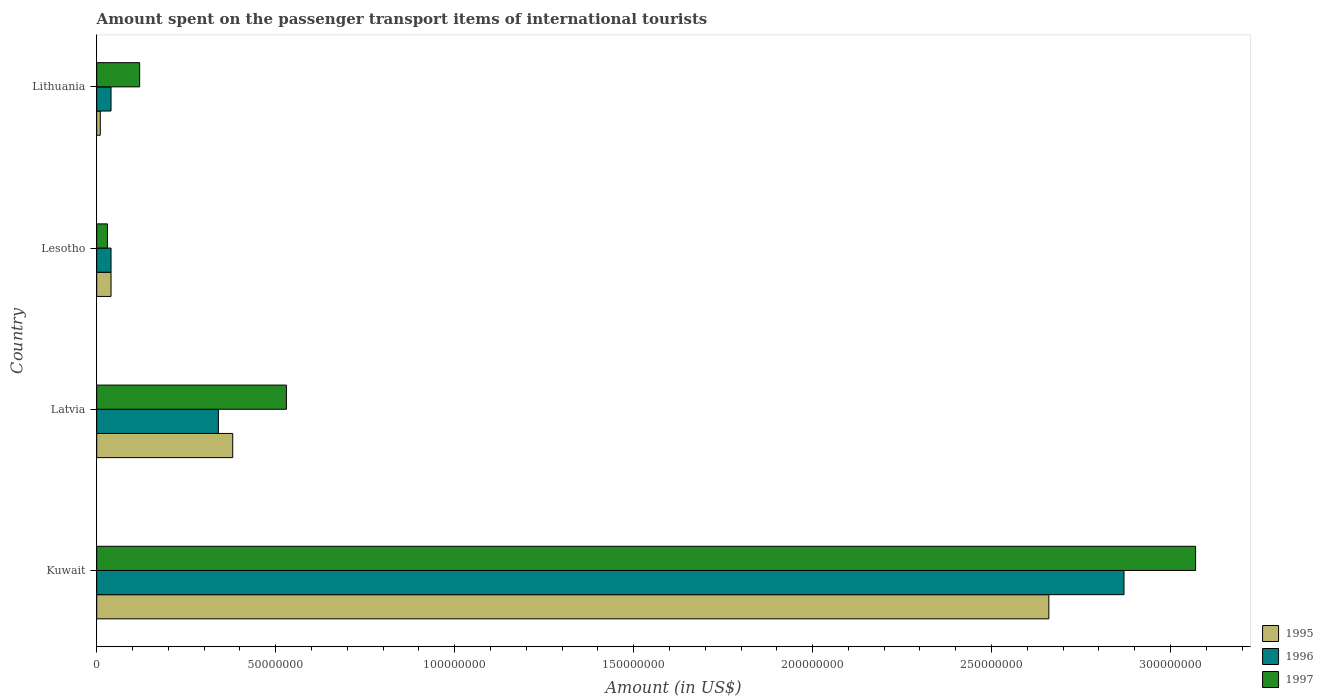How many different coloured bars are there?
Provide a short and direct response. 3. How many groups of bars are there?
Offer a very short reply. 4. Are the number of bars per tick equal to the number of legend labels?
Give a very brief answer. Yes. How many bars are there on the 3rd tick from the top?
Keep it short and to the point. 3. How many bars are there on the 4th tick from the bottom?
Offer a terse response. 3. What is the label of the 2nd group of bars from the top?
Ensure brevity in your answer.  Lesotho. In how many cases, is the number of bars for a given country not equal to the number of legend labels?
Your response must be concise. 0. Across all countries, what is the maximum amount spent on the passenger transport items of international tourists in 1997?
Keep it short and to the point. 3.07e+08. In which country was the amount spent on the passenger transport items of international tourists in 1996 maximum?
Make the answer very short. Kuwait. In which country was the amount spent on the passenger transport items of international tourists in 1996 minimum?
Offer a terse response. Lesotho. What is the total amount spent on the passenger transport items of international tourists in 1997 in the graph?
Make the answer very short. 3.75e+08. What is the difference between the amount spent on the passenger transport items of international tourists in 1995 in Kuwait and the amount spent on the passenger transport items of international tourists in 1996 in Lithuania?
Your response must be concise. 2.62e+08. What is the average amount spent on the passenger transport items of international tourists in 1997 per country?
Give a very brief answer. 9.38e+07. What is the difference between the amount spent on the passenger transport items of international tourists in 1997 and amount spent on the passenger transport items of international tourists in 1995 in Lithuania?
Offer a very short reply. 1.10e+07. What is the ratio of the amount spent on the passenger transport items of international tourists in 1996 in Latvia to that in Lithuania?
Ensure brevity in your answer.  8.5. Is the amount spent on the passenger transport items of international tourists in 1997 in Kuwait less than that in Lesotho?
Your answer should be very brief. No. Is the difference between the amount spent on the passenger transport items of international tourists in 1997 in Kuwait and Lesotho greater than the difference between the amount spent on the passenger transport items of international tourists in 1995 in Kuwait and Lesotho?
Offer a very short reply. Yes. What is the difference between the highest and the second highest amount spent on the passenger transport items of international tourists in 1995?
Give a very brief answer. 2.28e+08. What is the difference between the highest and the lowest amount spent on the passenger transport items of international tourists in 1996?
Your answer should be compact. 2.83e+08. In how many countries, is the amount spent on the passenger transport items of international tourists in 1996 greater than the average amount spent on the passenger transport items of international tourists in 1996 taken over all countries?
Your answer should be compact. 1. What does the 3rd bar from the top in Kuwait represents?
Make the answer very short. 1995. What does the 2nd bar from the bottom in Lesotho represents?
Provide a short and direct response. 1996. Is it the case that in every country, the sum of the amount spent on the passenger transport items of international tourists in 1995 and amount spent on the passenger transport items of international tourists in 1996 is greater than the amount spent on the passenger transport items of international tourists in 1997?
Provide a short and direct response. No. What is the difference between two consecutive major ticks on the X-axis?
Provide a succinct answer. 5.00e+07. Does the graph contain any zero values?
Your answer should be compact. No. Where does the legend appear in the graph?
Offer a terse response. Bottom right. How many legend labels are there?
Provide a short and direct response. 3. How are the legend labels stacked?
Your answer should be compact. Vertical. What is the title of the graph?
Offer a terse response. Amount spent on the passenger transport items of international tourists. What is the Amount (in US$) in 1995 in Kuwait?
Your answer should be compact. 2.66e+08. What is the Amount (in US$) of 1996 in Kuwait?
Your answer should be compact. 2.87e+08. What is the Amount (in US$) of 1997 in Kuwait?
Your response must be concise. 3.07e+08. What is the Amount (in US$) of 1995 in Latvia?
Provide a short and direct response. 3.80e+07. What is the Amount (in US$) of 1996 in Latvia?
Your answer should be compact. 3.40e+07. What is the Amount (in US$) in 1997 in Latvia?
Your response must be concise. 5.30e+07. What is the Amount (in US$) in 1995 in Lesotho?
Your answer should be very brief. 4.00e+06. What is the Amount (in US$) of 1996 in Lesotho?
Offer a terse response. 4.00e+06. What is the Amount (in US$) in 1997 in Lesotho?
Keep it short and to the point. 3.00e+06. What is the Amount (in US$) in 1996 in Lithuania?
Offer a terse response. 4.00e+06. What is the Amount (in US$) of 1997 in Lithuania?
Offer a very short reply. 1.20e+07. Across all countries, what is the maximum Amount (in US$) in 1995?
Make the answer very short. 2.66e+08. Across all countries, what is the maximum Amount (in US$) in 1996?
Provide a short and direct response. 2.87e+08. Across all countries, what is the maximum Amount (in US$) of 1997?
Offer a very short reply. 3.07e+08. Across all countries, what is the minimum Amount (in US$) in 1995?
Ensure brevity in your answer.  1.00e+06. What is the total Amount (in US$) in 1995 in the graph?
Your answer should be compact. 3.09e+08. What is the total Amount (in US$) of 1996 in the graph?
Provide a short and direct response. 3.29e+08. What is the total Amount (in US$) of 1997 in the graph?
Your response must be concise. 3.75e+08. What is the difference between the Amount (in US$) of 1995 in Kuwait and that in Latvia?
Offer a terse response. 2.28e+08. What is the difference between the Amount (in US$) in 1996 in Kuwait and that in Latvia?
Your response must be concise. 2.53e+08. What is the difference between the Amount (in US$) in 1997 in Kuwait and that in Latvia?
Offer a terse response. 2.54e+08. What is the difference between the Amount (in US$) of 1995 in Kuwait and that in Lesotho?
Provide a succinct answer. 2.62e+08. What is the difference between the Amount (in US$) in 1996 in Kuwait and that in Lesotho?
Offer a terse response. 2.83e+08. What is the difference between the Amount (in US$) of 1997 in Kuwait and that in Lesotho?
Ensure brevity in your answer.  3.04e+08. What is the difference between the Amount (in US$) of 1995 in Kuwait and that in Lithuania?
Offer a terse response. 2.65e+08. What is the difference between the Amount (in US$) in 1996 in Kuwait and that in Lithuania?
Make the answer very short. 2.83e+08. What is the difference between the Amount (in US$) of 1997 in Kuwait and that in Lithuania?
Your answer should be compact. 2.95e+08. What is the difference between the Amount (in US$) of 1995 in Latvia and that in Lesotho?
Offer a very short reply. 3.40e+07. What is the difference between the Amount (in US$) in 1996 in Latvia and that in Lesotho?
Ensure brevity in your answer.  3.00e+07. What is the difference between the Amount (in US$) in 1995 in Latvia and that in Lithuania?
Give a very brief answer. 3.70e+07. What is the difference between the Amount (in US$) in 1996 in Latvia and that in Lithuania?
Your answer should be very brief. 3.00e+07. What is the difference between the Amount (in US$) in 1997 in Latvia and that in Lithuania?
Offer a terse response. 4.10e+07. What is the difference between the Amount (in US$) in 1996 in Lesotho and that in Lithuania?
Provide a short and direct response. 0. What is the difference between the Amount (in US$) in 1997 in Lesotho and that in Lithuania?
Your response must be concise. -9.00e+06. What is the difference between the Amount (in US$) of 1995 in Kuwait and the Amount (in US$) of 1996 in Latvia?
Make the answer very short. 2.32e+08. What is the difference between the Amount (in US$) in 1995 in Kuwait and the Amount (in US$) in 1997 in Latvia?
Provide a short and direct response. 2.13e+08. What is the difference between the Amount (in US$) of 1996 in Kuwait and the Amount (in US$) of 1997 in Latvia?
Keep it short and to the point. 2.34e+08. What is the difference between the Amount (in US$) of 1995 in Kuwait and the Amount (in US$) of 1996 in Lesotho?
Give a very brief answer. 2.62e+08. What is the difference between the Amount (in US$) of 1995 in Kuwait and the Amount (in US$) of 1997 in Lesotho?
Provide a short and direct response. 2.63e+08. What is the difference between the Amount (in US$) in 1996 in Kuwait and the Amount (in US$) in 1997 in Lesotho?
Give a very brief answer. 2.84e+08. What is the difference between the Amount (in US$) of 1995 in Kuwait and the Amount (in US$) of 1996 in Lithuania?
Give a very brief answer. 2.62e+08. What is the difference between the Amount (in US$) in 1995 in Kuwait and the Amount (in US$) in 1997 in Lithuania?
Provide a short and direct response. 2.54e+08. What is the difference between the Amount (in US$) in 1996 in Kuwait and the Amount (in US$) in 1997 in Lithuania?
Keep it short and to the point. 2.75e+08. What is the difference between the Amount (in US$) in 1995 in Latvia and the Amount (in US$) in 1996 in Lesotho?
Offer a terse response. 3.40e+07. What is the difference between the Amount (in US$) of 1995 in Latvia and the Amount (in US$) of 1997 in Lesotho?
Offer a very short reply. 3.50e+07. What is the difference between the Amount (in US$) of 1996 in Latvia and the Amount (in US$) of 1997 in Lesotho?
Make the answer very short. 3.10e+07. What is the difference between the Amount (in US$) of 1995 in Latvia and the Amount (in US$) of 1996 in Lithuania?
Keep it short and to the point. 3.40e+07. What is the difference between the Amount (in US$) in 1995 in Latvia and the Amount (in US$) in 1997 in Lithuania?
Provide a succinct answer. 2.60e+07. What is the difference between the Amount (in US$) of 1996 in Latvia and the Amount (in US$) of 1997 in Lithuania?
Make the answer very short. 2.20e+07. What is the difference between the Amount (in US$) of 1995 in Lesotho and the Amount (in US$) of 1997 in Lithuania?
Offer a very short reply. -8.00e+06. What is the difference between the Amount (in US$) of 1996 in Lesotho and the Amount (in US$) of 1997 in Lithuania?
Your answer should be very brief. -8.00e+06. What is the average Amount (in US$) of 1995 per country?
Offer a terse response. 7.72e+07. What is the average Amount (in US$) in 1996 per country?
Your response must be concise. 8.22e+07. What is the average Amount (in US$) in 1997 per country?
Provide a succinct answer. 9.38e+07. What is the difference between the Amount (in US$) in 1995 and Amount (in US$) in 1996 in Kuwait?
Your answer should be very brief. -2.10e+07. What is the difference between the Amount (in US$) of 1995 and Amount (in US$) of 1997 in Kuwait?
Offer a terse response. -4.10e+07. What is the difference between the Amount (in US$) of 1996 and Amount (in US$) of 1997 in Kuwait?
Provide a succinct answer. -2.00e+07. What is the difference between the Amount (in US$) of 1995 and Amount (in US$) of 1997 in Latvia?
Your response must be concise. -1.50e+07. What is the difference between the Amount (in US$) of 1996 and Amount (in US$) of 1997 in Latvia?
Offer a very short reply. -1.90e+07. What is the difference between the Amount (in US$) in 1995 and Amount (in US$) in 1996 in Lesotho?
Provide a short and direct response. 0. What is the difference between the Amount (in US$) of 1995 and Amount (in US$) of 1996 in Lithuania?
Make the answer very short. -3.00e+06. What is the difference between the Amount (in US$) in 1995 and Amount (in US$) in 1997 in Lithuania?
Make the answer very short. -1.10e+07. What is the difference between the Amount (in US$) in 1996 and Amount (in US$) in 1997 in Lithuania?
Provide a short and direct response. -8.00e+06. What is the ratio of the Amount (in US$) of 1995 in Kuwait to that in Latvia?
Ensure brevity in your answer.  7. What is the ratio of the Amount (in US$) in 1996 in Kuwait to that in Latvia?
Offer a terse response. 8.44. What is the ratio of the Amount (in US$) in 1997 in Kuwait to that in Latvia?
Offer a terse response. 5.79. What is the ratio of the Amount (in US$) in 1995 in Kuwait to that in Lesotho?
Offer a terse response. 66.5. What is the ratio of the Amount (in US$) of 1996 in Kuwait to that in Lesotho?
Offer a terse response. 71.75. What is the ratio of the Amount (in US$) in 1997 in Kuwait to that in Lesotho?
Give a very brief answer. 102.33. What is the ratio of the Amount (in US$) in 1995 in Kuwait to that in Lithuania?
Give a very brief answer. 266. What is the ratio of the Amount (in US$) in 1996 in Kuwait to that in Lithuania?
Your response must be concise. 71.75. What is the ratio of the Amount (in US$) in 1997 in Kuwait to that in Lithuania?
Give a very brief answer. 25.58. What is the ratio of the Amount (in US$) in 1995 in Latvia to that in Lesotho?
Make the answer very short. 9.5. What is the ratio of the Amount (in US$) of 1997 in Latvia to that in Lesotho?
Offer a very short reply. 17.67. What is the ratio of the Amount (in US$) of 1996 in Latvia to that in Lithuania?
Offer a very short reply. 8.5. What is the ratio of the Amount (in US$) in 1997 in Latvia to that in Lithuania?
Provide a short and direct response. 4.42. What is the ratio of the Amount (in US$) of 1995 in Lesotho to that in Lithuania?
Offer a very short reply. 4. What is the ratio of the Amount (in US$) of 1996 in Lesotho to that in Lithuania?
Your response must be concise. 1. What is the ratio of the Amount (in US$) of 1997 in Lesotho to that in Lithuania?
Your answer should be very brief. 0.25. What is the difference between the highest and the second highest Amount (in US$) in 1995?
Provide a short and direct response. 2.28e+08. What is the difference between the highest and the second highest Amount (in US$) of 1996?
Keep it short and to the point. 2.53e+08. What is the difference between the highest and the second highest Amount (in US$) in 1997?
Ensure brevity in your answer.  2.54e+08. What is the difference between the highest and the lowest Amount (in US$) of 1995?
Your answer should be compact. 2.65e+08. What is the difference between the highest and the lowest Amount (in US$) of 1996?
Offer a very short reply. 2.83e+08. What is the difference between the highest and the lowest Amount (in US$) in 1997?
Make the answer very short. 3.04e+08. 